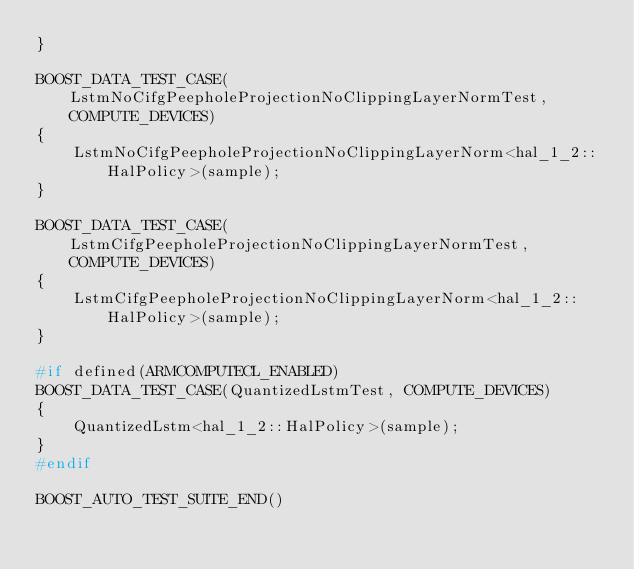<code> <loc_0><loc_0><loc_500><loc_500><_C++_>}

BOOST_DATA_TEST_CASE(LstmNoCifgPeepholeProjectionNoClippingLayerNormTest, COMPUTE_DEVICES)
{
    LstmNoCifgPeepholeProjectionNoClippingLayerNorm<hal_1_2::HalPolicy>(sample);
}

BOOST_DATA_TEST_CASE(LstmCifgPeepholeProjectionNoClippingLayerNormTest, COMPUTE_DEVICES)
{
    LstmCifgPeepholeProjectionNoClippingLayerNorm<hal_1_2::HalPolicy>(sample);
}

#if defined(ARMCOMPUTECL_ENABLED)
BOOST_DATA_TEST_CASE(QuantizedLstmTest, COMPUTE_DEVICES)
{
    QuantizedLstm<hal_1_2::HalPolicy>(sample);
}
#endif

BOOST_AUTO_TEST_SUITE_END()
</code> 